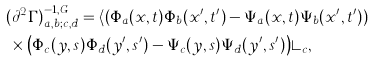Convert formula to latex. <formula><loc_0><loc_0><loc_500><loc_500>& ( \partial ^ { 2 } \Gamma ) ^ { - 1 , G } _ { a , b ; c , d } = \langle \left ( \Phi _ { a } ( { x } , t ) \Phi _ { b } ( { x } ^ { \prime } , t ^ { \prime } ) - \Psi _ { a } ( { x } , t ) \Psi _ { b } ( { x } ^ { \prime } , t ^ { \prime } ) \right ) \\ & \, \times \left ( \Phi _ { c } ( { y } , s ) \Phi _ { d } ( { y } ^ { \prime } , s ^ { \prime } ) - \Psi _ { c } ( { y } , s ) \Psi _ { d } ( { y } ^ { \prime } , s ^ { \prime } ) \right ) \rangle _ { c } ,</formula> 